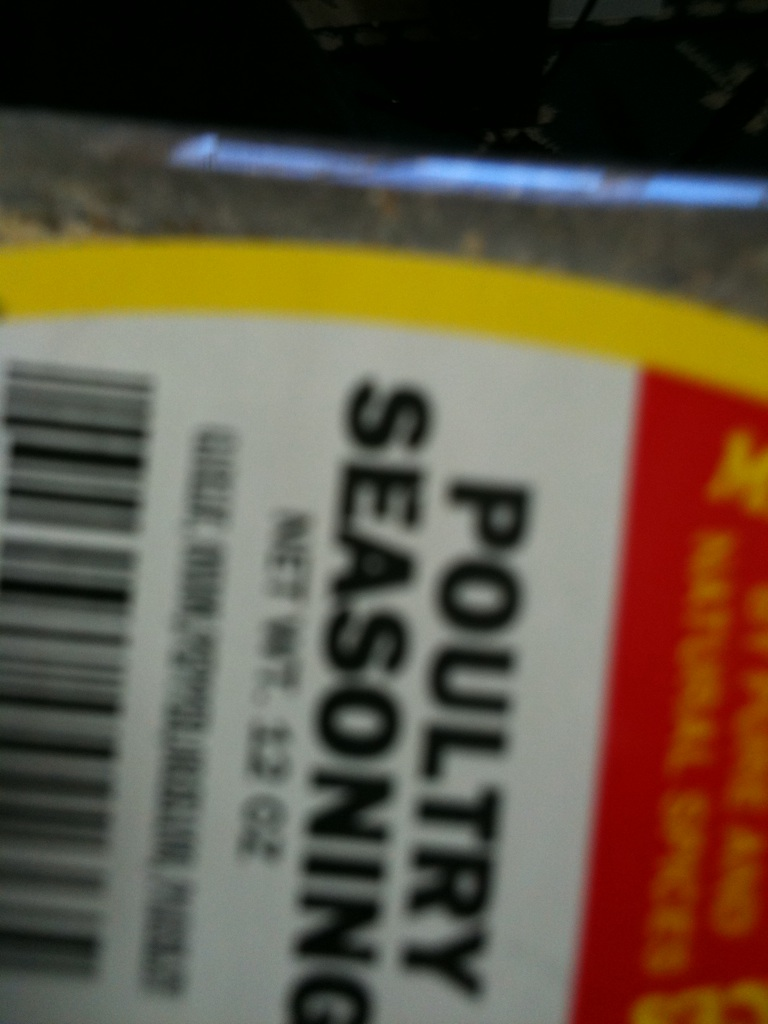What dishes can I use this poultry seasoning in? Poultry seasoning is fantastic for a variety of dishes beyond just poultry. You can incorporate it into stuffing, soups, and even vegetable dishes. It imparts a warm, traditional flavor that's particularly great in comfort foods like casseroles and pot pies.  Are there any dietary considerations with this spice? Most poultry seasoning blends are all-natural and do not contain added sugars, artificial flavors, or preservatives, making them suitable for various dietary preferences. However, it's always important to check the label for specific allergens or dietary restrictions, such as gluten or salt content. 